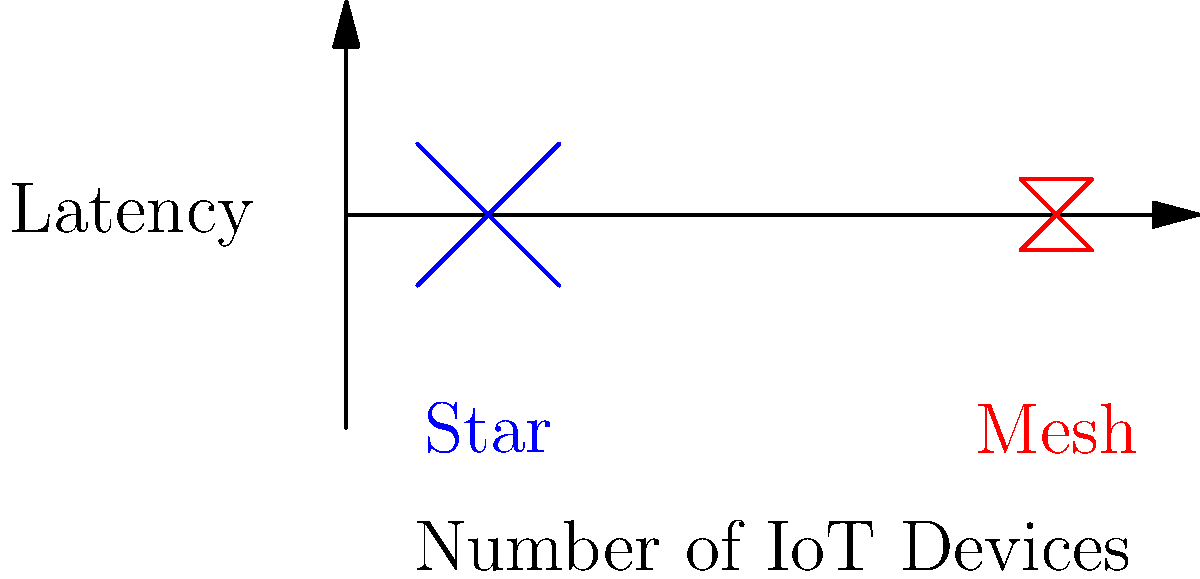Based on the graph comparing star and mesh network topologies for IoT device deployments, which topology is likely to provide lower latency as the number of devices increases? To determine which topology provides lower latency as the number of IoT devices increases, let's analyze the graph step-by-step:

1. The x-axis represents the number of IoT devices, while the y-axis represents latency.

2. The blue lines represent the star topology:
   - It shows a steeper upward slope as the number of devices increases.
   - This indicates that latency increases more rapidly with additional devices.

3. The red lines represent the mesh topology:
   - It shows a gentler upward slope as the number of devices increases.
   - This suggests that latency increases more slowly with additional devices.

4. Comparing the two topologies:
   - At lower device counts, the star topology may have slightly lower latency.
   - As the number of devices increases, the mesh topology's line remains lower than the star topology's line.

5. The reason for this difference:
   - In a star topology, all devices communicate through a central node, creating a bottleneck as the number of devices grows.
   - In a mesh topology, devices can communicate directly with each other, distributing the network load more evenly.

6. Conclusion:
   - As the number of IoT devices increases, the mesh topology is likely to provide lower latency compared to the star topology.
Answer: Mesh topology 